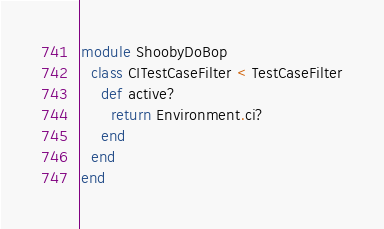<code> <loc_0><loc_0><loc_500><loc_500><_Ruby_>module ShoobyDoBop
  class CITestCaseFilter < TestCaseFilter
    def active?
      return Environment.ci?
    end
  end
end
</code> 